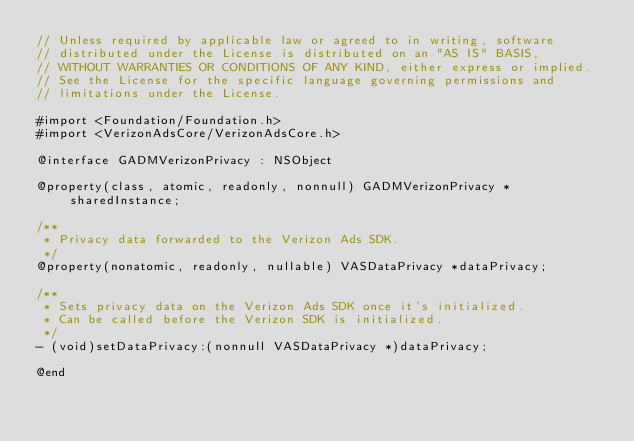Convert code to text. <code><loc_0><loc_0><loc_500><loc_500><_C_>// Unless required by applicable law or agreed to in writing, software
// distributed under the License is distributed on an "AS IS" BASIS,
// WITHOUT WARRANTIES OR CONDITIONS OF ANY KIND, either express or implied.
// See the License for the specific language governing permissions and
// limitations under the License.

#import <Foundation/Foundation.h>
#import <VerizonAdsCore/VerizonAdsCore.h>

@interface GADMVerizonPrivacy : NSObject

@property(class, atomic, readonly, nonnull) GADMVerizonPrivacy *sharedInstance;

/**
 * Privacy data forwarded to the Verizon Ads SDK.
 */
@property(nonatomic, readonly, nullable) VASDataPrivacy *dataPrivacy;

/**
 * Sets privacy data on the Verizon Ads SDK once it's initialized.
 * Can be called before the Verizon SDK is initialized.
 */
- (void)setDataPrivacy:(nonnull VASDataPrivacy *)dataPrivacy;

@end
</code> 